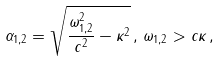Convert formula to latex. <formula><loc_0><loc_0><loc_500><loc_500>\alpha _ { 1 , 2 } = \sqrt { \frac { \omega _ { 1 , 2 } ^ { 2 } } { c ^ { 2 } } - \kappa ^ { 2 } } \, , \, \omega _ { 1 , 2 } > c \kappa \, ,</formula> 